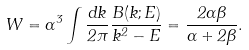<formula> <loc_0><loc_0><loc_500><loc_500>W = \alpha ^ { 3 } \int \frac { d k } { 2 \pi } \frac { B ( k ; E ) } { k ^ { 2 } - E } = \frac { 2 \alpha \beta } { \alpha + 2 \beta } .</formula> 